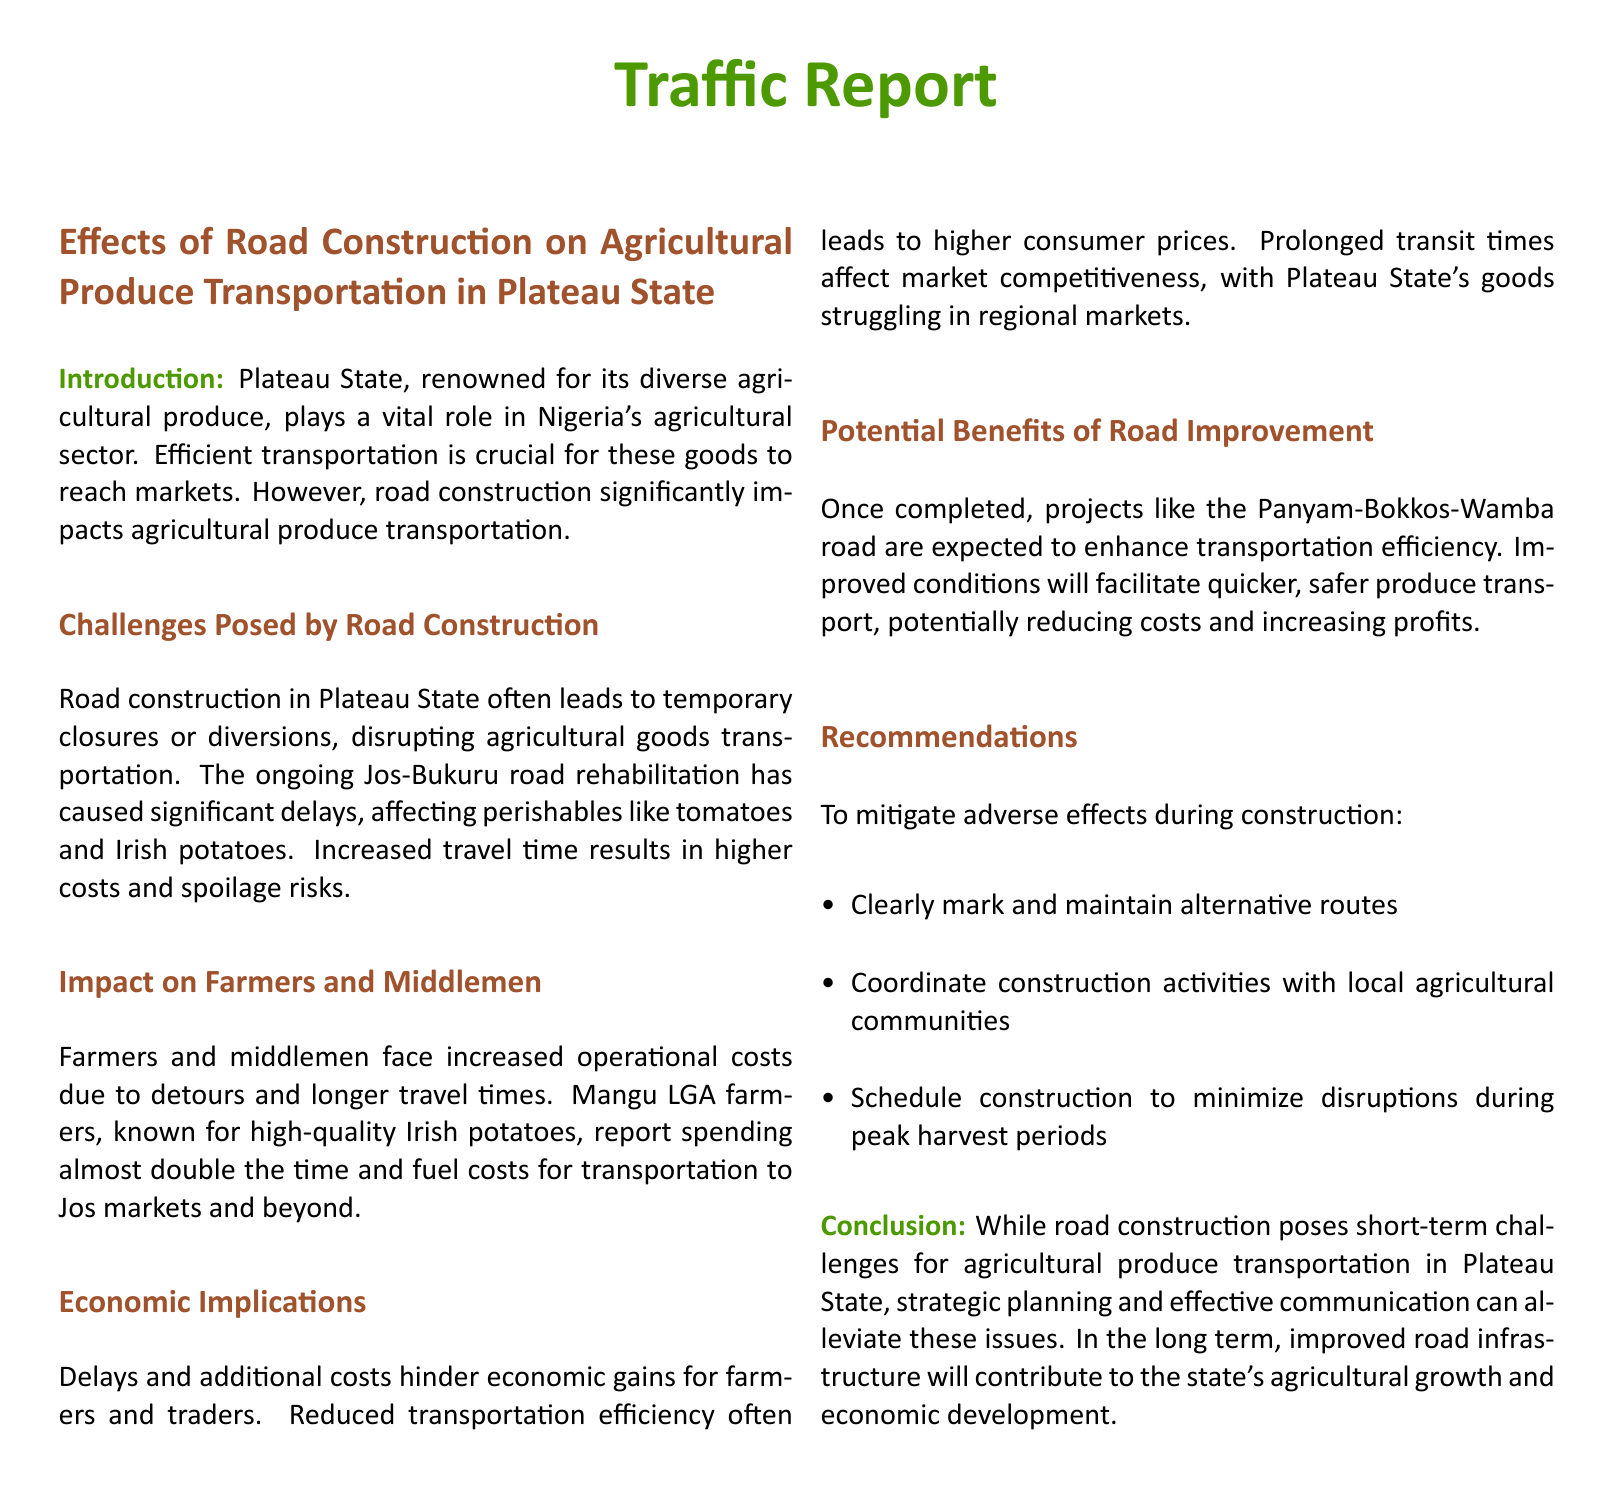What is the main agricultural product mentioned? The primary agricultural products impacted by road construction include perishables like tomatoes and Irish potatoes.
Answer: tomatoes and Irish potatoes What is the impact of road construction on transportation costs? Road construction leads to increased operational costs for farmers and middlemen due to detours and longer travel times.
Answer: increased operational costs Which road is currently undergoing rehabilitation? The document specifically mentions the ongoing Jos-Bukuru road rehabilitation affecting transportation.
Answer: Jos-Bukuru What is one potential benefit of road improvement projects? Improved road conditions will facilitate quicker, safer produce transport, potentially reducing costs and increasing profits.
Answer: quicker, safer produce transport What do Mangu LGA farmers report regarding their transportation time? Mangu LGA farmers report spending almost double the time and fuel costs for transportation to markets due to the road construction.
Answer: almost double What should be coordinated with local agricultural communities? Construction activities should be coordinated to minimize disruptions during peak harvest periods.
Answer: construction activities What is one recommendation for mitigating adverse effects during construction? One recommendation is to clearly mark and maintain alternative routes to ensure smooth transportation during the construction period.
Answer: clearly mark and maintain alternative routes What is the overall conclusion regarding road construction's effect on agriculture? The conclusion states that road construction poses short-term challenges but that improved road infrastructure will contribute to agricultural growth.
Answer: short-term challenges What is a key economic implication mentioned in the report? Delays and additional transportation costs hinder economic gains for farmers and traders, leading to higher consumer prices.
Answer: higher consumer prices What color is used for the section headings in the report? The section headings in the report are colored in earth brown, representing a natural and earthy tone.
Answer: earth brown 